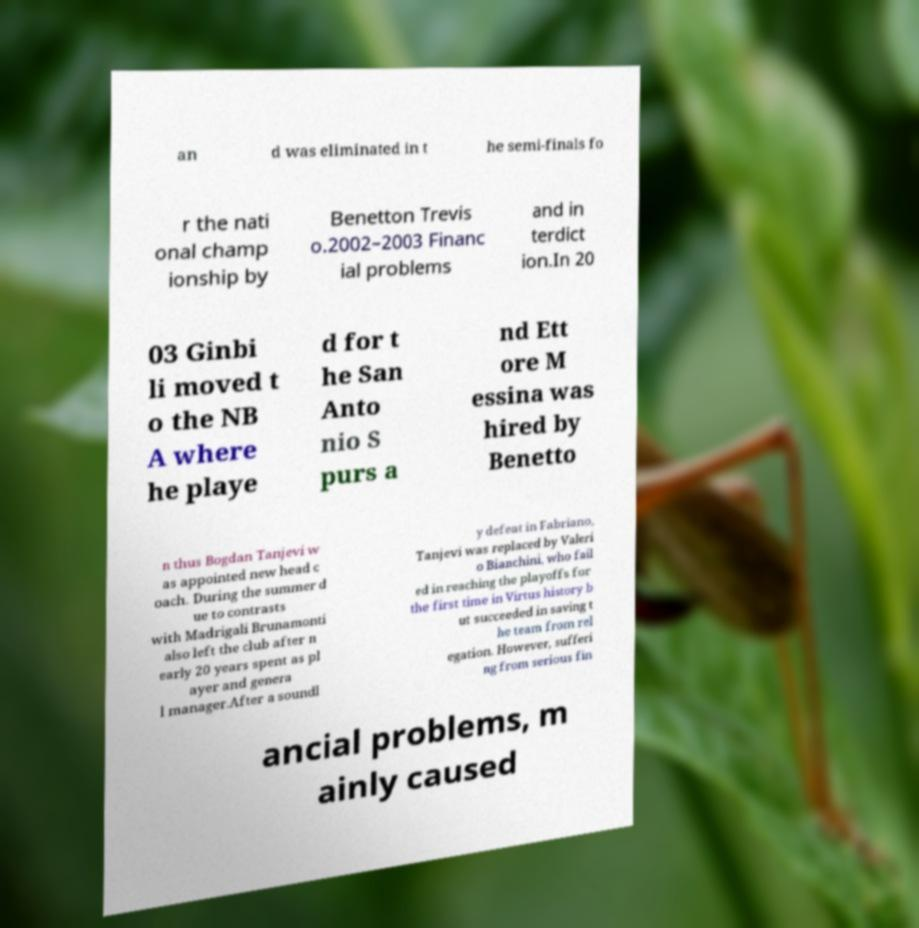There's text embedded in this image that I need extracted. Can you transcribe it verbatim? an d was eliminated in t he semi-finals fo r the nati onal champ ionship by Benetton Trevis o.2002–2003 Financ ial problems and in terdict ion.In 20 03 Ginbi li moved t o the NB A where he playe d for t he San Anto nio S purs a nd Ett ore M essina was hired by Benetto n thus Bogdan Tanjevi w as appointed new head c oach. During the summer d ue to contrasts with Madrigali Brunamonti also left the club after n early 20 years spent as pl ayer and genera l manager.After a soundl y defeat in Fabriano, Tanjevi was replaced by Valeri o Bianchini, who fail ed in reaching the playoffs for the first time in Virtus history b ut succeeded in saving t he team from rel egation. However, sufferi ng from serious fin ancial problems, m ainly caused 